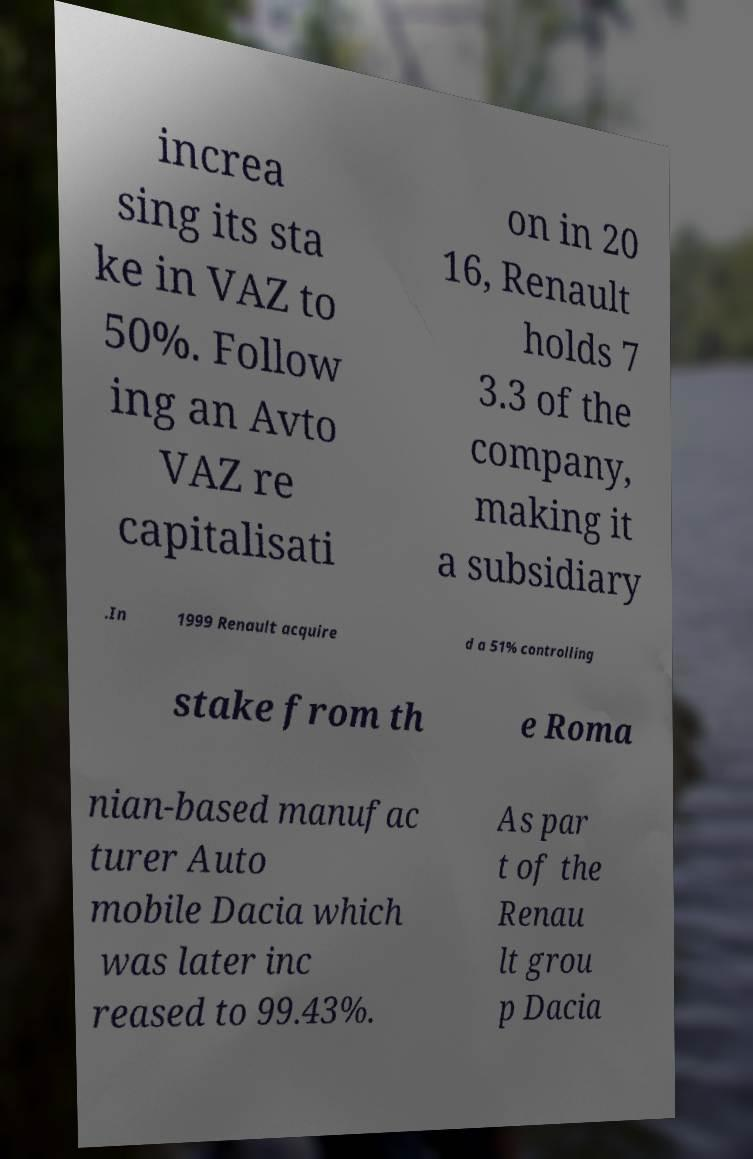Please identify and transcribe the text found in this image. increa sing its sta ke in VAZ to 50%. Follow ing an Avto VAZ re capitalisati on in 20 16, Renault holds 7 3.3 of the company, making it a subsidiary .In 1999 Renault acquire d a 51% controlling stake from th e Roma nian-based manufac turer Auto mobile Dacia which was later inc reased to 99.43%. As par t of the Renau lt grou p Dacia 